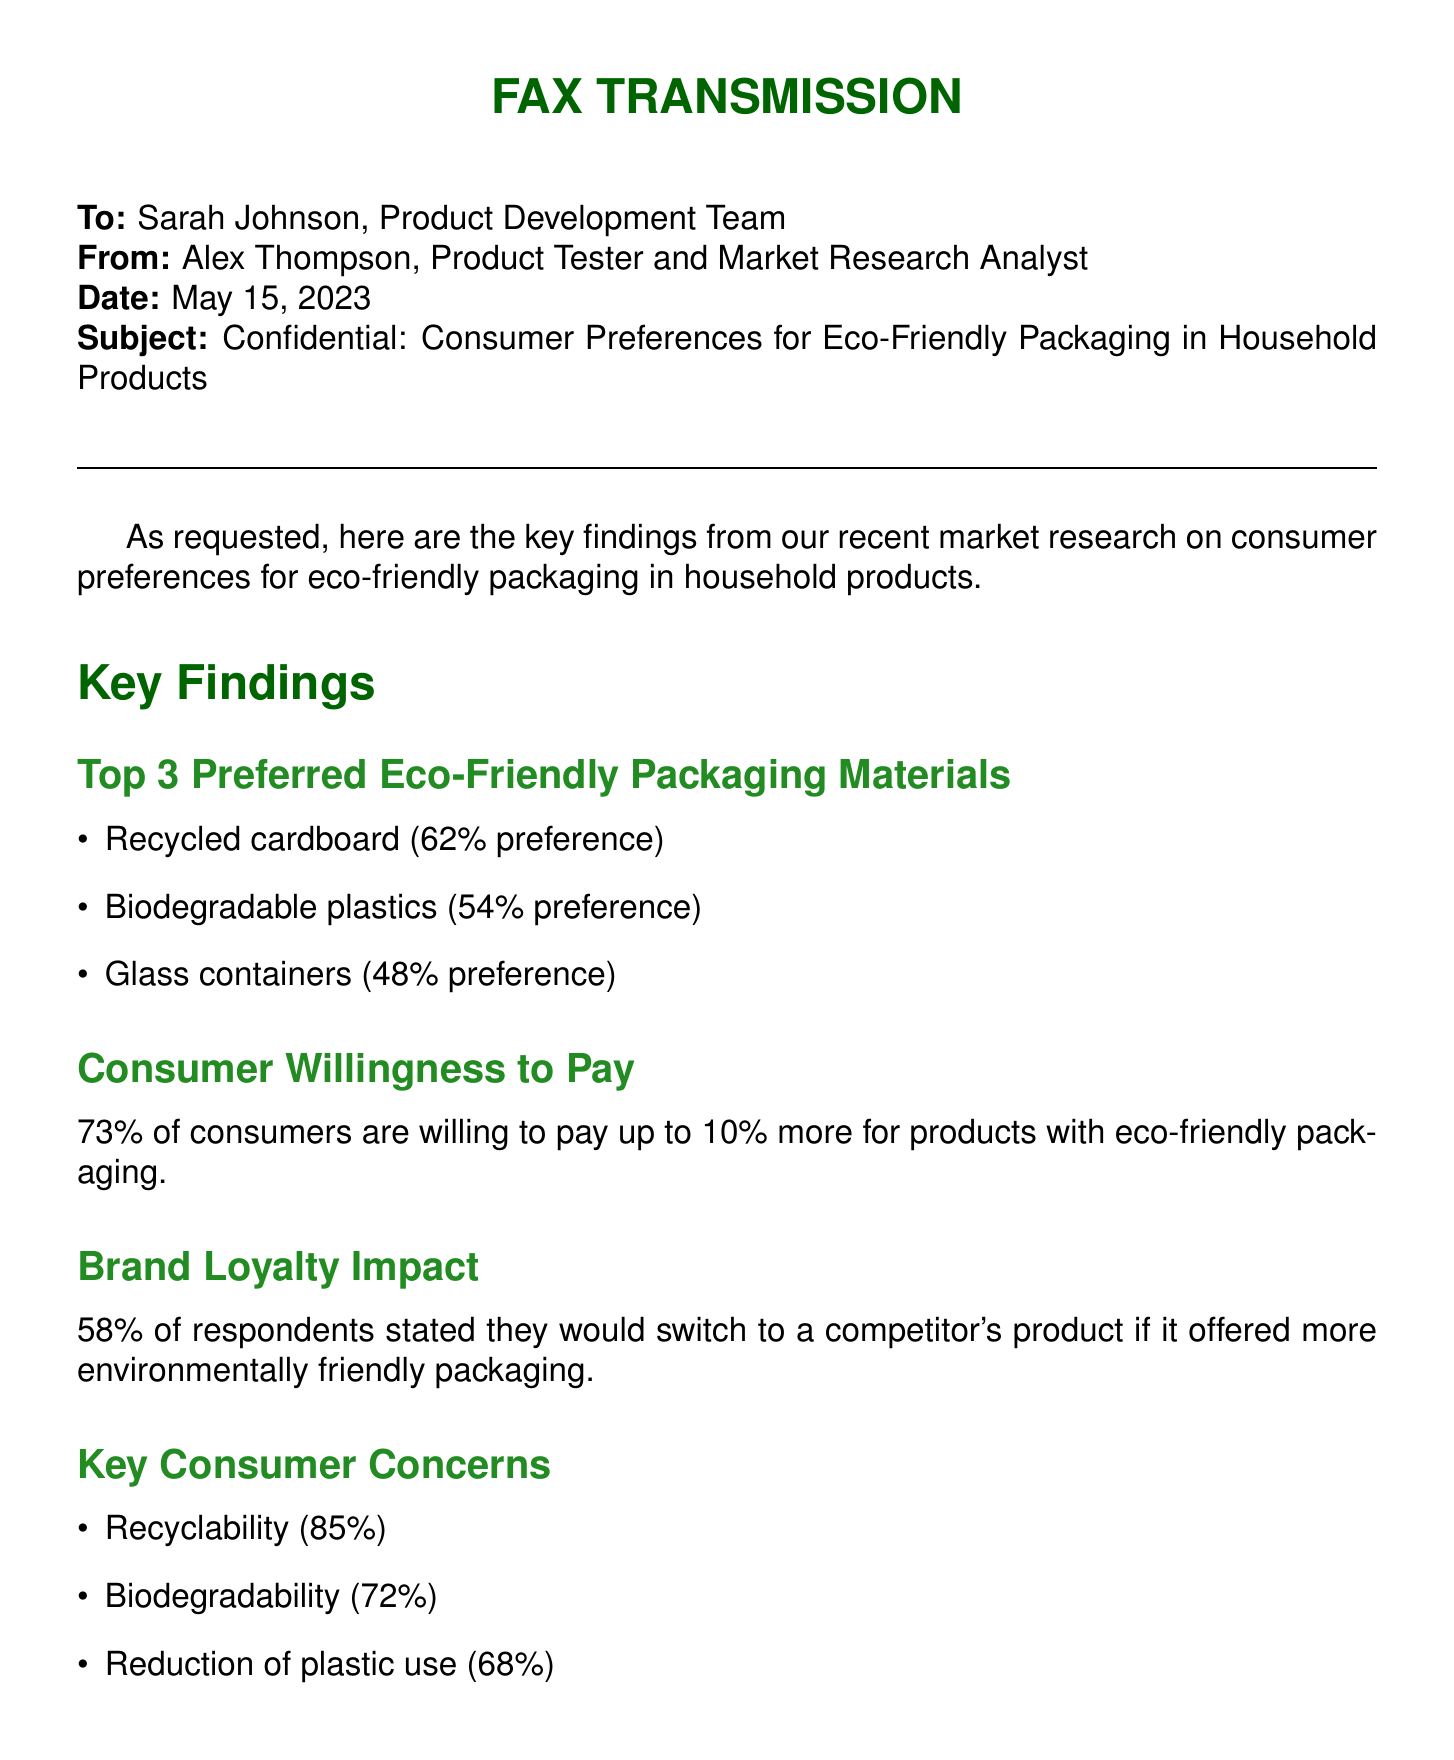What are the top three preferred eco-friendly packaging materials? The document lists the top three eco-friendly packaging materials preferred by consumers as recycled cardboard, biodegradable plastics, and glass containers.
Answer: Recycled cardboard, biodegradable plastics, glass containers What percentage of consumers prefer recycled cardboard? The document specifies that 62% of consumers prefer recycled cardboard as an eco-friendly packaging material.
Answer: 62% What is the percentage of consumers willing to pay more for eco-friendly packaging? The document states that 73% of consumers are willing to pay up to 10% more for products with eco-friendly packaging.
Answer: 73% What concern do 85% of consumers have regarding eco-friendly packaging? According to the document, 85% of consumers express concern about recyclability in eco-friendly packaging.
Answer: Recyclability What is the impact on brand loyalty if a competitor offers better packaging? The document indicates that 58% of respondents would switch to a competitor's product if it offered more environmentally friendly packaging.
Answer: 58% What recommendation is made regarding packaging materials? The document concludes with a recommendation to incorporate recycled cardboard and biodegradable plastics in packaging designs.
Answer: Recycled cardboard and biodegradable plastics Who is the sender of the fax? The sender mentioned in the document is Alex Thompson, a Product Tester and Market Research Analyst.
Answer: Alex Thompson What date was the fax transmitted? The document specifies that the fax was transmitted on May 15, 2023.
Answer: May 15, 2023 What does the disclaimer at the end of the document state? The disclaimer indicates that the information is confidential and intended for internal use only, asking for discretion in handling it.
Answer: Confidential and intended for internal use only 